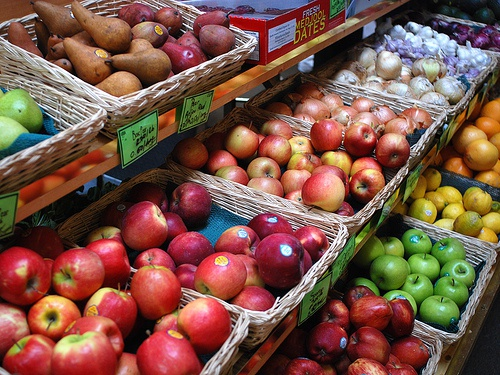Describe the objects in this image and their specific colors. I can see apple in maroon, brown, salmon, and black tones, apple in maroon, black, brown, and salmon tones, apple in maroon, black, brown, and salmon tones, apple in maroon, black, and brown tones, and apple in maroon, green, lightgreen, black, and darkgreen tones in this image. 